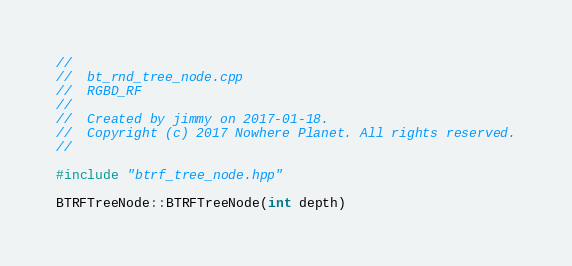<code> <loc_0><loc_0><loc_500><loc_500><_C++_>//
//  bt_rnd_tree_node.cpp
//  RGBD_RF
//
//  Created by jimmy on 2017-01-18.
//  Copyright (c) 2017 Nowhere Planet. All rights reserved.
//

#include "btrf_tree_node.hpp"

BTRFTreeNode::BTRFTreeNode(int depth)</code> 